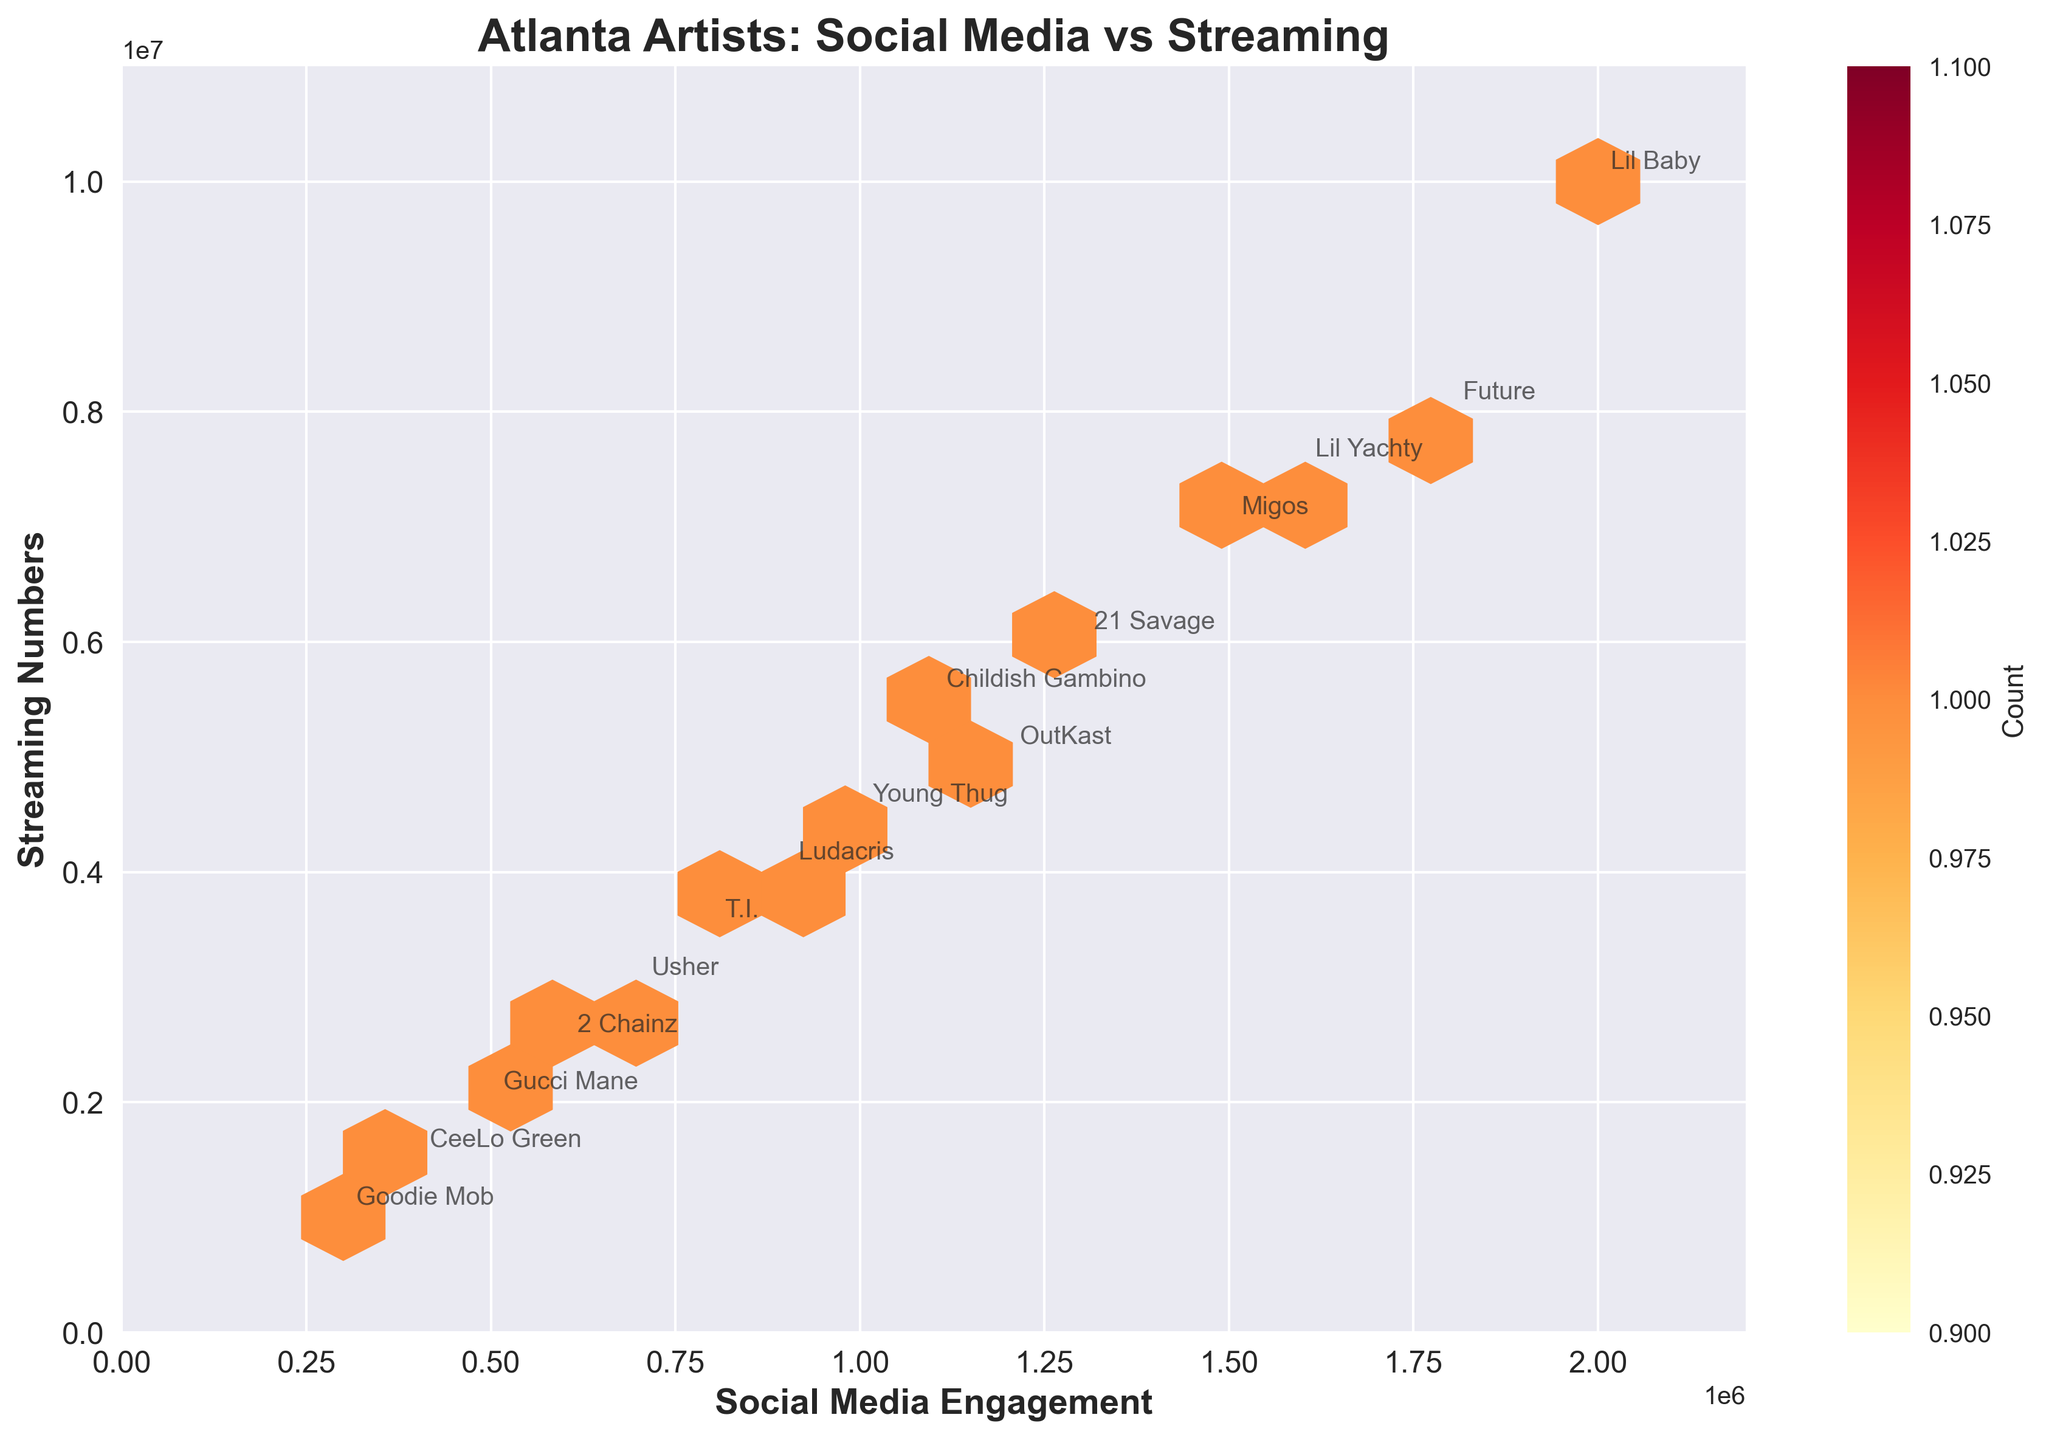What is the title of the Hexbin Plot? The title is located at the top center of the plot, and it is usually the largest text on the plot.
Answer: Atlanta Artists: Social Media vs Streaming What do the x-axis and y-axis represent? The x-axis represents Social Media Engagement, and the y-axis represents Streaming Numbers. This information is clearly labeled on the plot with bold text next to each axis.
Answer: Social Media Engagement and Streaming Numbers Which artist has the highest social media engagement? To find this, look at the data point farthest to the right along the x-axis. It's labeled next to the data point.
Answer: Lil Baby Which artist has the lowest streaming numbers? To determine this, locate the data point that is closest to the bottom along the y-axis and read the label next to it.
Answer: Goodie Mob Are there any artists with similar social media engagement, but different streaming numbers? By examining the plot, look for data points that are at roughly the same position horizontally (similar x-values) but are at different vertical positions (different y-values).
Answer: Yes, 2 Chainz and Gucci Mane Which artists have social media engagement between 1,000,000 and 1,500,000? Identify the data points that fall within the x-axis range from 1,000,000 to 1,500,000 and note the labels of these points.
Answer: Young Thug, Childish Gambino, OutKast, 21 Savage What is the average streaming number for artists with over 1,000,000 social media engagements? Look for the data points to the right of the 1,000,000 mark on the x-axis, sum their y-values (streaming numbers), and divide by the number of such artists: (5M + 7M + 10M + 8M + 4.5M + 6M + 5.5M + 7.5M) / 8.
Answer: 6,312,500 Who are the artists with both social media engagements and streaming numbers above 1,500,000? Identify the data points that are above 1,500,000 on both axes by examining both the horizontal and vertical positions, then read the labels.
Answer: Migos, Lil Baby, Future, 21 Savage, Lil Yachty Do most artists with high streaming numbers also have high social media engagement? To assess this, observe whether the majority of data points with high y-values (streaming numbers) are also positioned far to the right on the x-axis (high social media engagement).
Answer: Yes What pattern or trend do you observe between social media engagement and streaming numbers in this plot? Notice the general direction of the concentration of data points. If the densities form a stretching pattern from the bottom-left to the top-right, it indicates a positive correlation where higher social media engagement tends to align with higher streaming numbers.
Answer: Positive correlation 